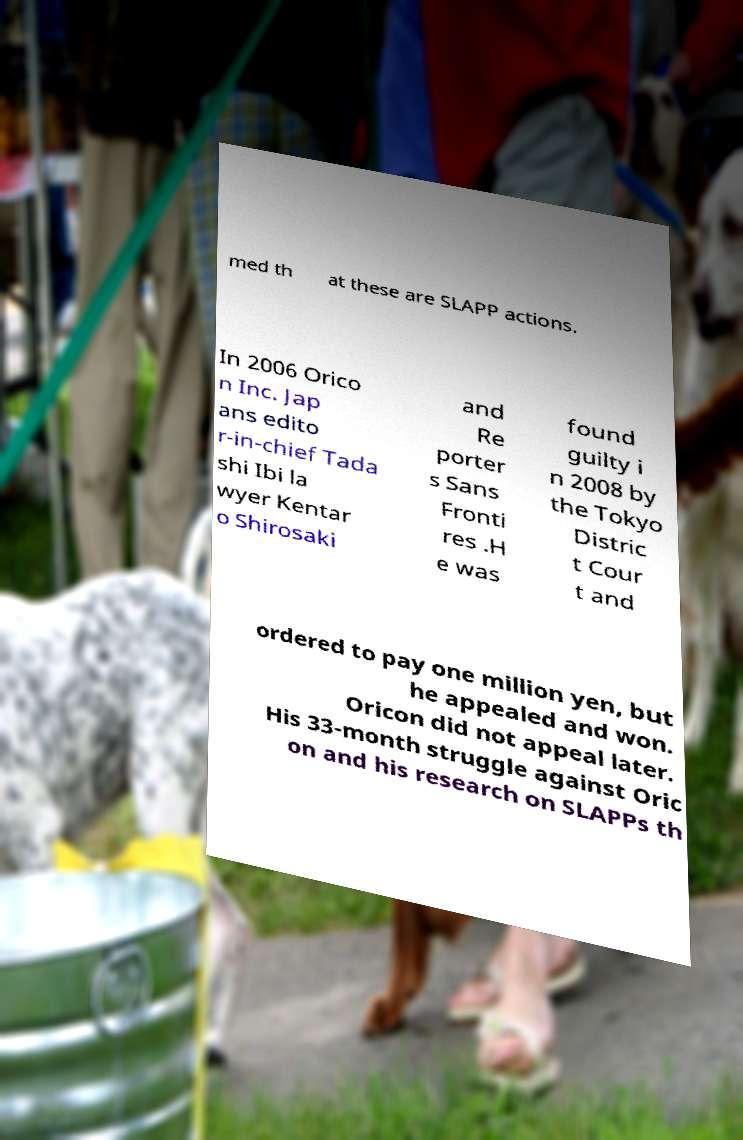Please read and relay the text visible in this image. What does it say? med th at these are SLAPP actions. In 2006 Orico n Inc. Jap ans edito r-in-chief Tada shi Ibi la wyer Kentar o Shirosaki and Re porter s Sans Fronti res .H e was found guilty i n 2008 by the Tokyo Distric t Cour t and ordered to pay one million yen, but he appealed and won. Oricon did not appeal later. His 33-month struggle against Oric on and his research on SLAPPs th 